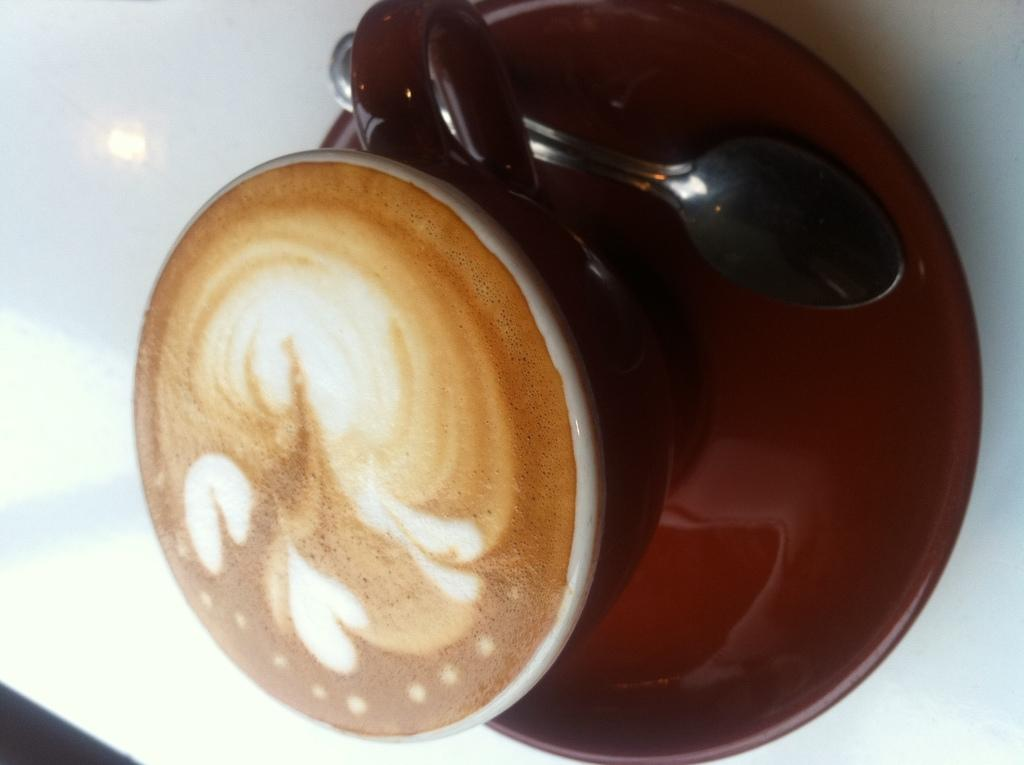What is in the image? There is a coffee cup in the image. How is the coffee cup positioned? The coffee cup is in a saucer. What is inside the coffee cup? There is a spoon in the coffee cup. Can you see any waves in the image? There are no waves present in the image; it features a coffee cup, saucer, and spoon. How many bags can be seen in the image? There are no bags present in the image. 